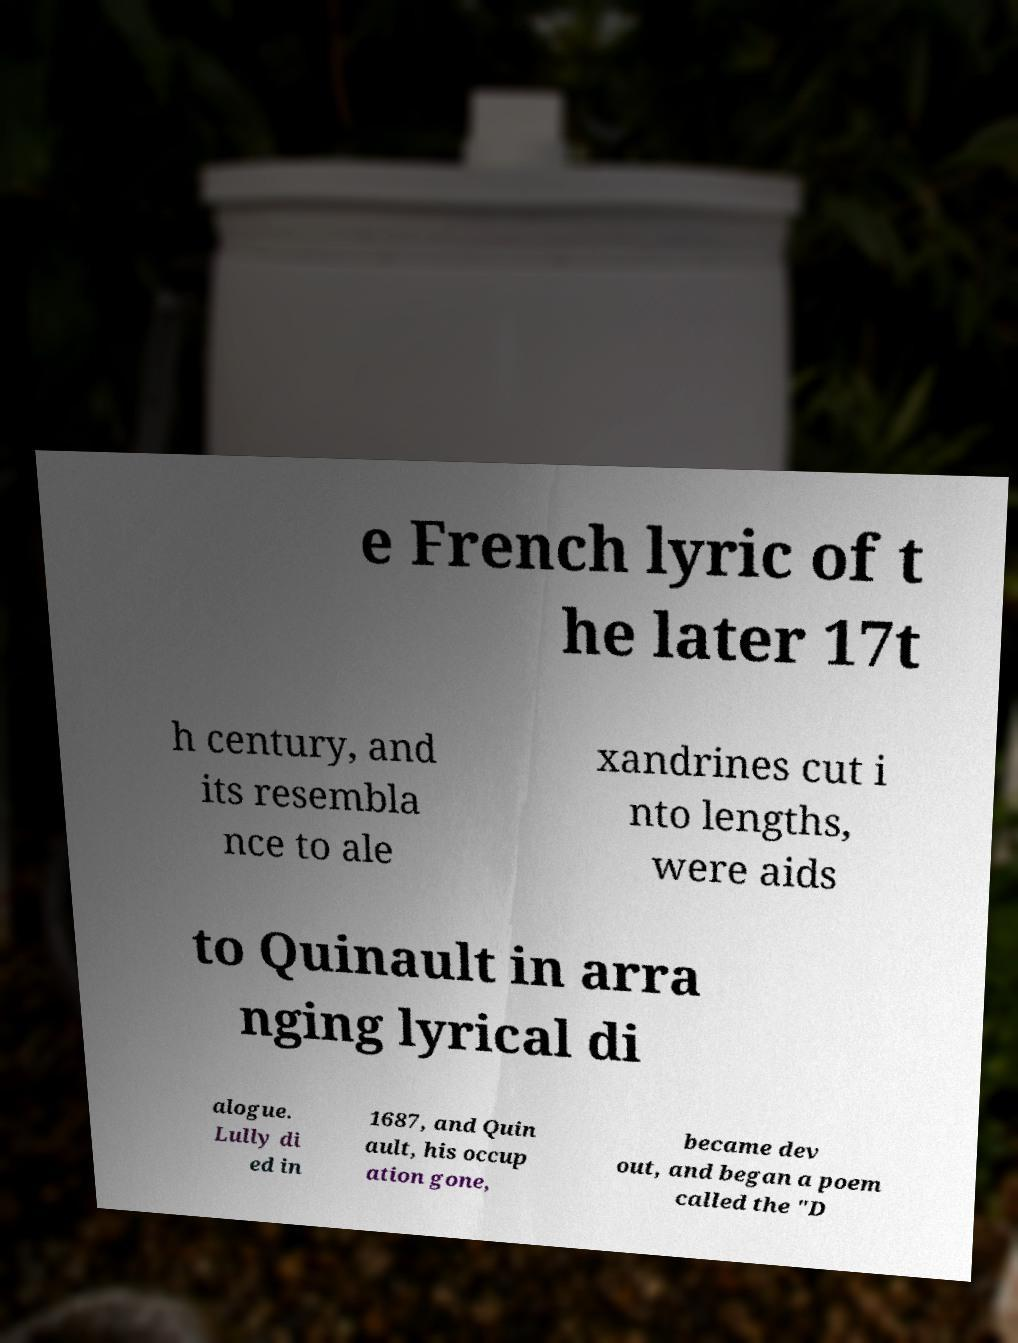I need the written content from this picture converted into text. Can you do that? e French lyric of t he later 17t h century, and its resembla nce to ale xandrines cut i nto lengths, were aids to Quinault in arra nging lyrical di alogue. Lully di ed in 1687, and Quin ault, his occup ation gone, became dev out, and began a poem called the "D 